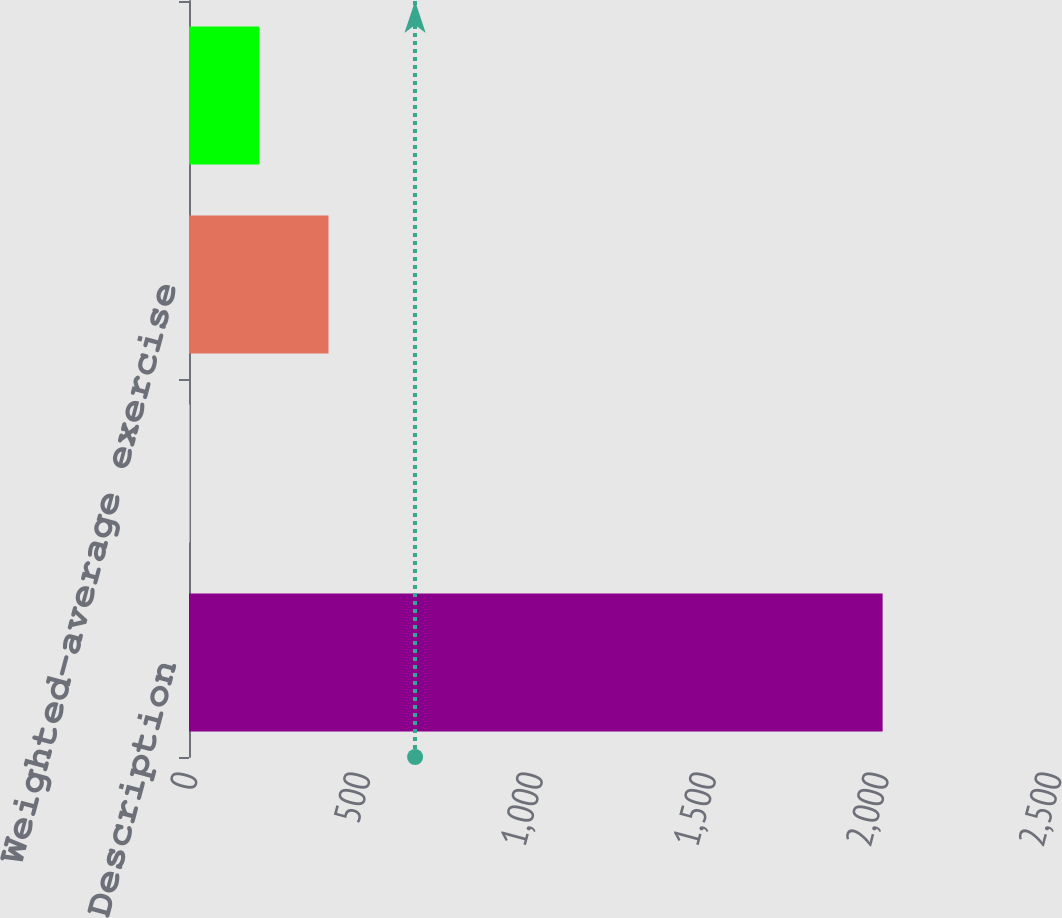Convert chart. <chart><loc_0><loc_0><loc_500><loc_500><bar_chart><fcel>Description<fcel>Average number of share<fcel>Weighted-average exercise<fcel>Options outstanding at<nl><fcel>2007<fcel>2.8<fcel>403.64<fcel>203.22<nl></chart> 